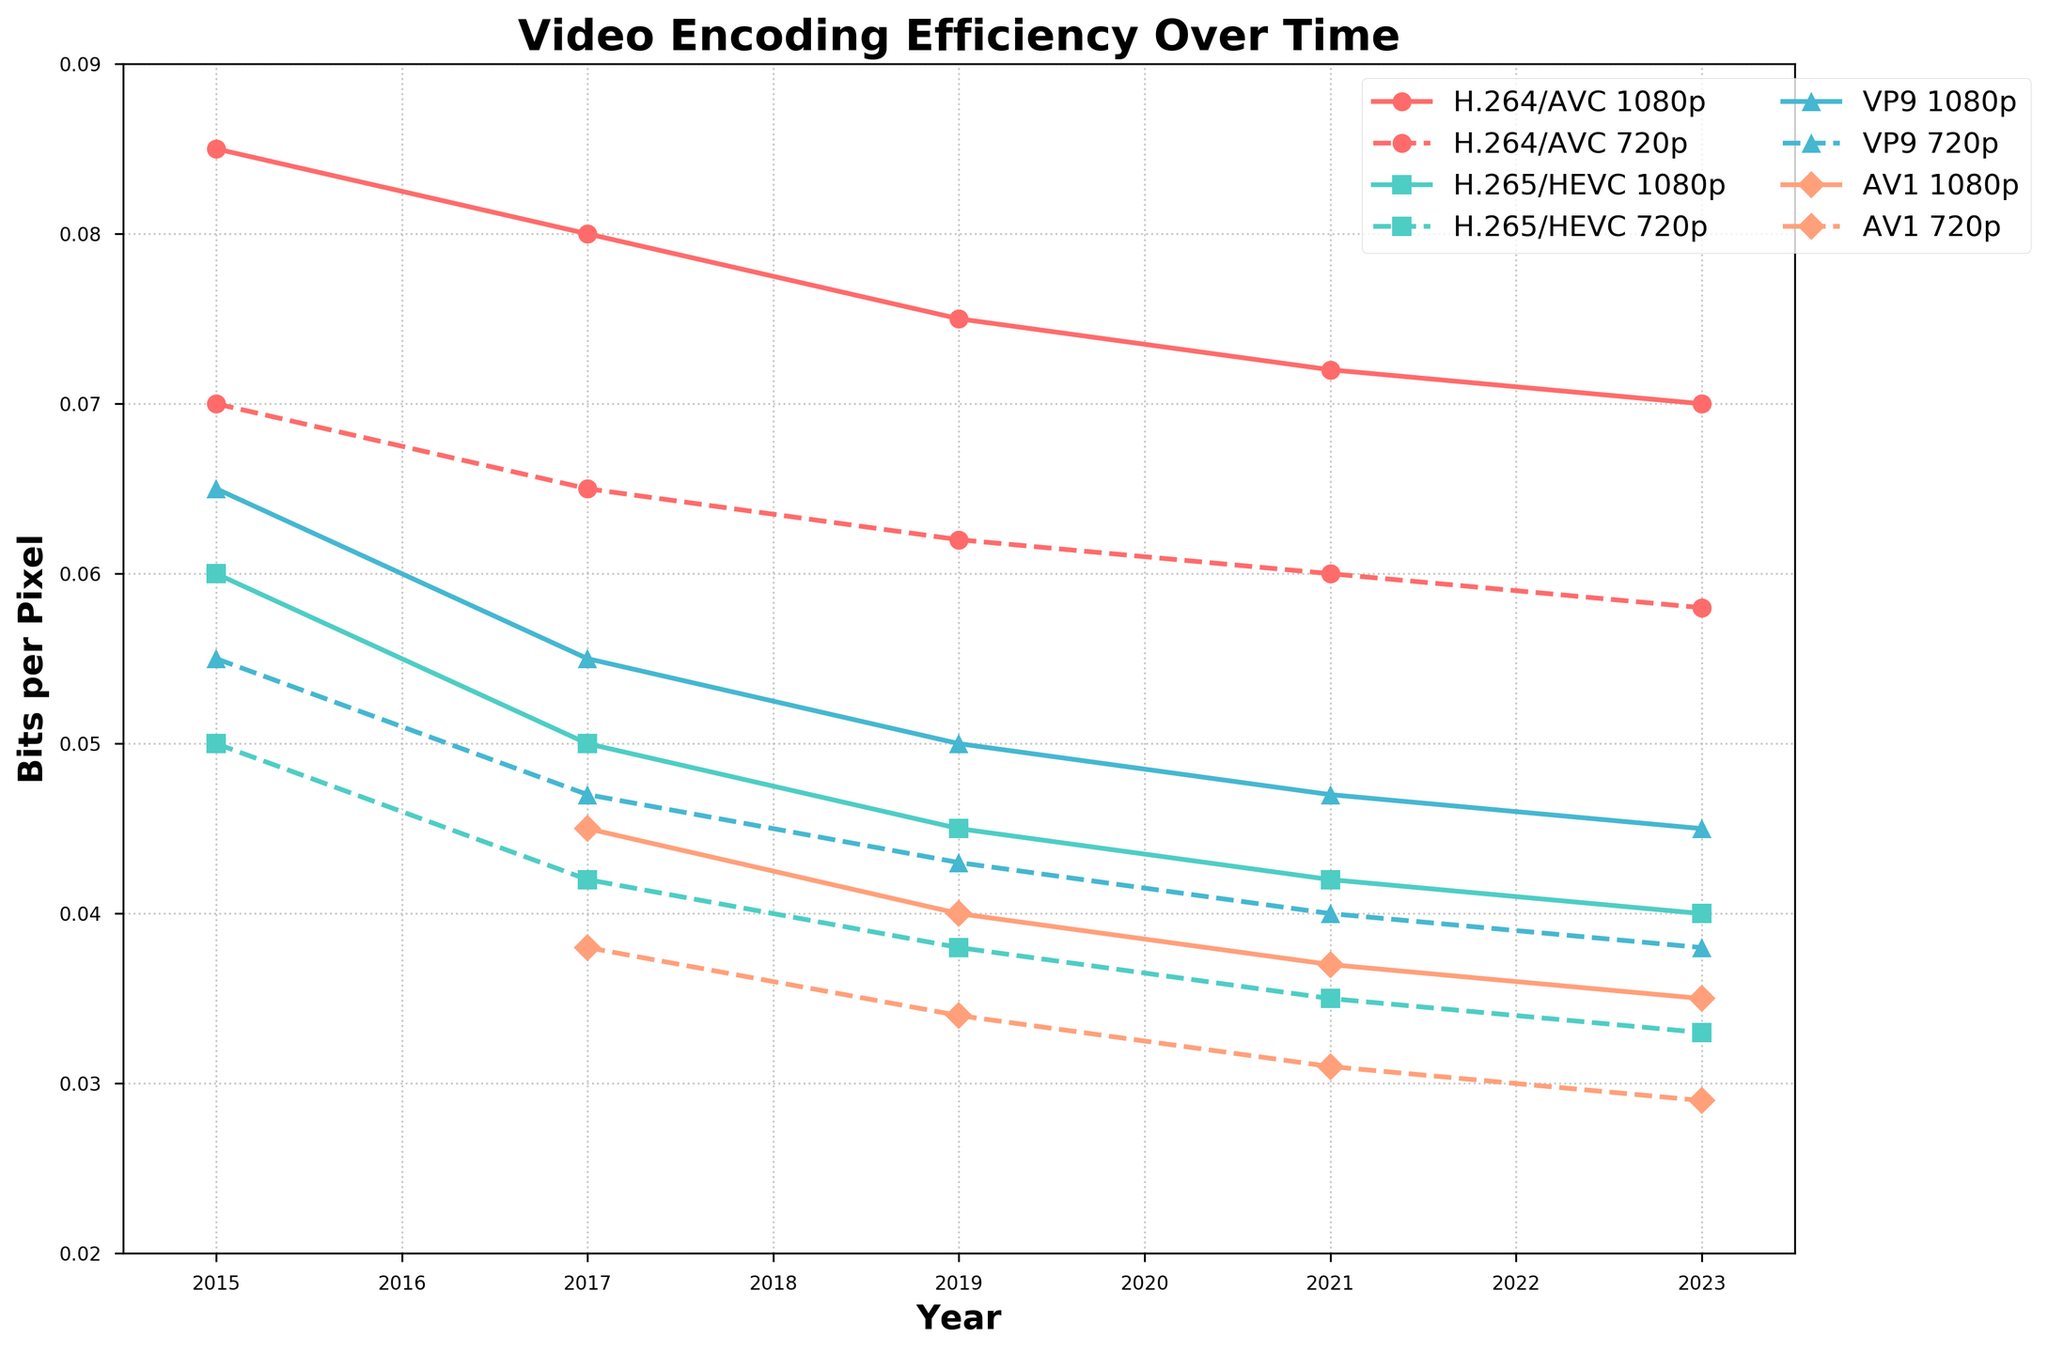What is the trend in bits per pixel for H.264/AVC codec from 2015 to 2023 for 1080p resolution? The bits per pixel for H.264/AVC 1080p shows a decreasing trend. In 2015, it was 0.085, then reduced to 0.080 in 2017, 0.075 in 2019, 0.072 in 2021, and finally 0.070 in 2023.
Answer: Decreasing Which codec had the greatest decrease in bits per pixel for 1080p resolution between 2015 and 2023? For H.264/AVC, the decrease is 0.085 - 0.070 = 0.015. For H.265/HEVC, the decrease is 0.060 - 0.040 = 0.020. For VP9, the decrease is 0.065 - 0.045 = 0.020. Since AV1 data is not available in 2015, it is excluded. Thus, H.265/HEVC and VP9 had the greatest decrease of 0.020.
Answer: H.265/HEVC and VP9 Comparing 2023 figures, which codec has the least bits per pixel at 720p resolution? In 2023, AV1 720p has 0.029 bits per pixel, which is the least compared to the other codecs.
Answer: AV1 Over which years does AV1 codec show data for both 1080p and 720p resolutions? AV1 codec shows data from 2017 to 2023 for both 1080p and 720p resolutions.
Answer: 2017 to 2023 What was the difference in bits per pixel for H.265/HEVC codec between 1080p and 720p in 2017? In 2017, H.265/HEVC for 1080p was 0.050 and for 720p was 0.042. The difference is 0.050 - 0.042 = 0.008.
Answer: 0.008 Which codec has the most constant bits per pixel trend for both resolutions from 2015 to 2023? By examining the trends, H.264/AVC shows the most constant trend, with a slight decrease compared to the other codecs with more significant changes.
Answer: H.264/AVC How did the encoding efficiency (bits per pixel) for VP9 1080p change from 2015 to 2019? In 2015, VP9 1080p was 0.065. By 2019, it changed to 0.050. The difference is 0.065 - 0.050 = 0.015.
Answer: Decreased by 0.015 By looking at the visual marks, which two codecs are represented using the same color but different markers? AV1 and VP9 are both represented using similar blue tones but different markers. AV1 uses circles while VP9 uses diamonds (based on the metadata where different codecs use different marker types).
Answer: AV1 and VP9 